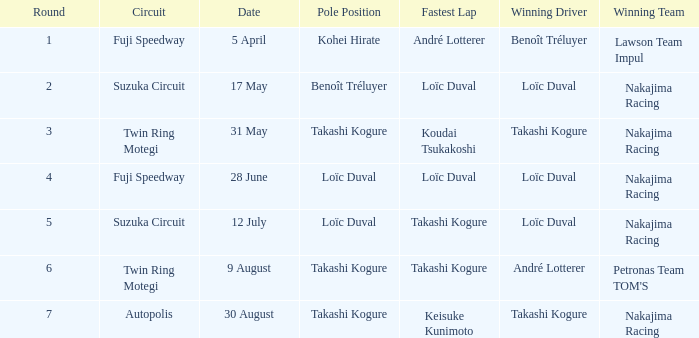In what earlier stage did takashi kogure secure the swiftest lap? 5.0. 